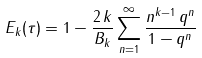Convert formula to latex. <formula><loc_0><loc_0><loc_500><loc_500>E _ { k } ( \tau ) = 1 - \frac { 2 \, k } { B _ { k } } \sum _ { n = 1 } ^ { \infty } \frac { n ^ { k - 1 } \, q ^ { n } } { 1 - q ^ { n } }</formula> 